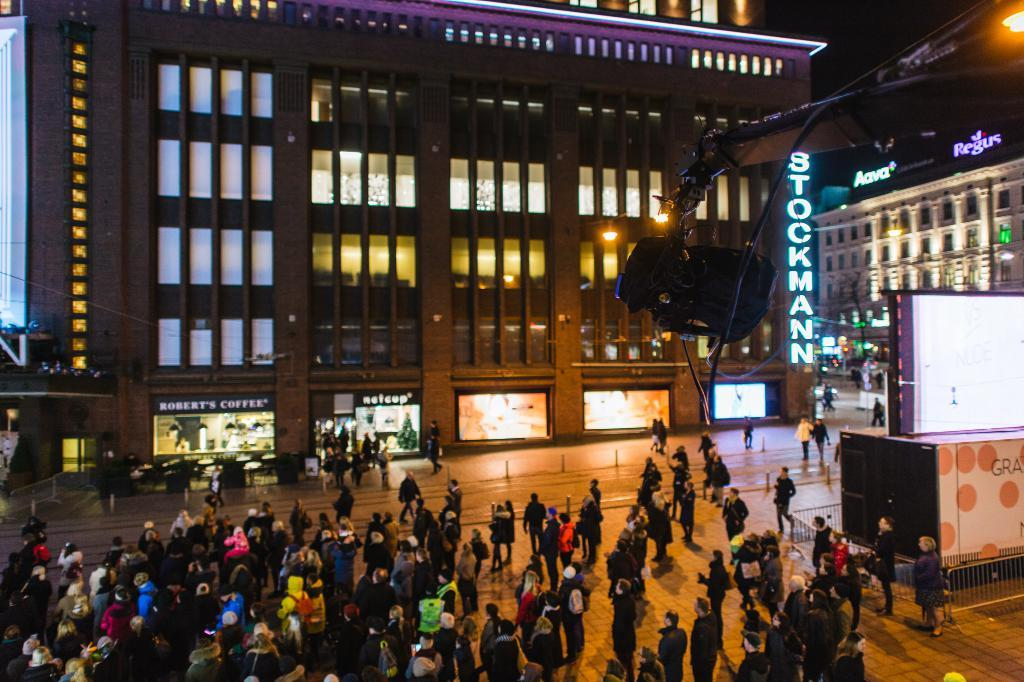<image>
Offer a succinct explanation of the picture presented. A building with the name Stockmann, with shops for Robert's coffee and Netcup at street level. 